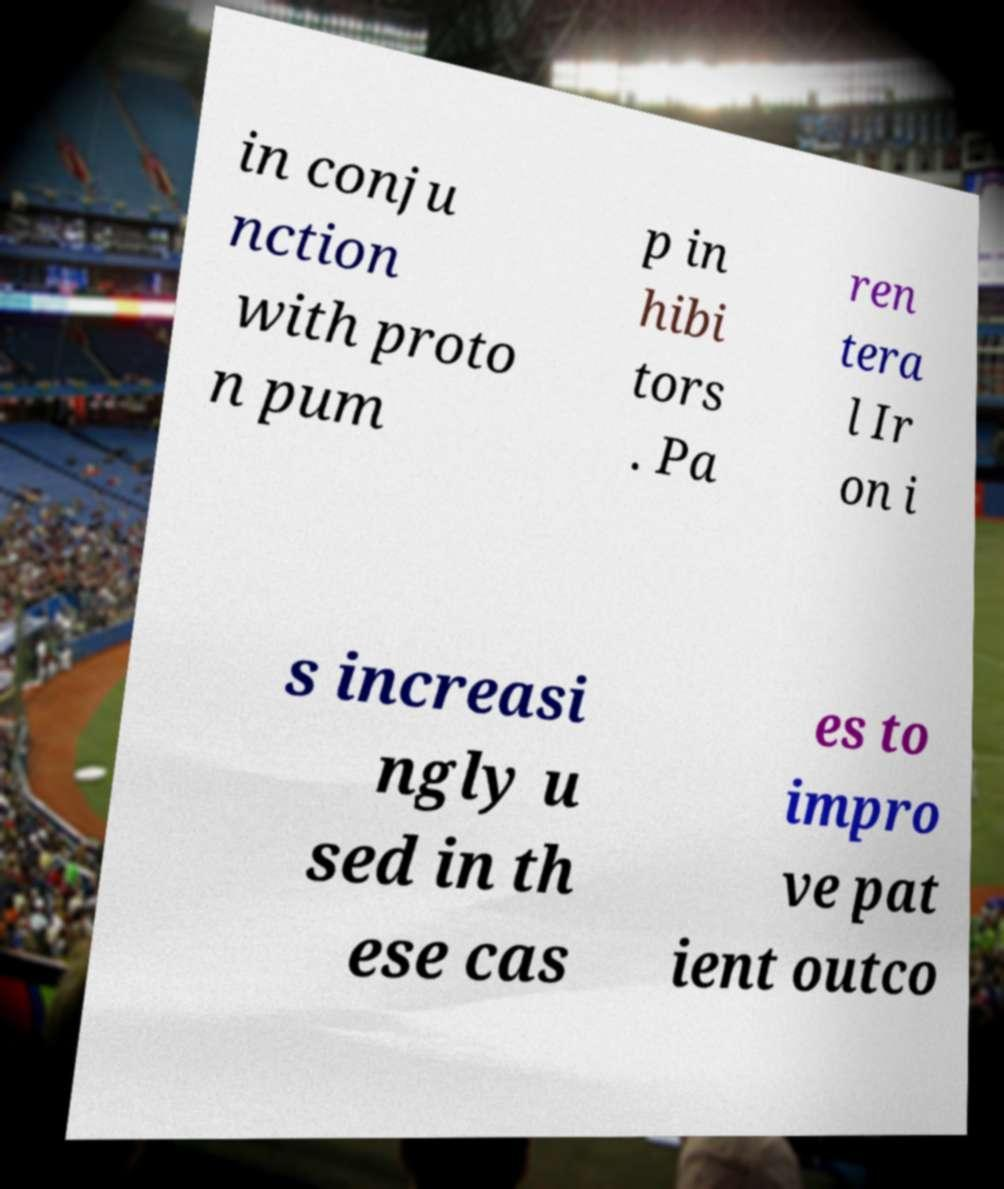Could you assist in decoding the text presented in this image and type it out clearly? in conju nction with proto n pum p in hibi tors . Pa ren tera l Ir on i s increasi ngly u sed in th ese cas es to impro ve pat ient outco 